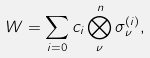<formula> <loc_0><loc_0><loc_500><loc_500>W = \sum _ { i = 0 } c _ { i } \bigotimes _ { \nu } ^ { n } \sigma _ { \nu } ^ { ( i ) } ,</formula> 